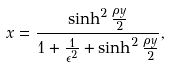Convert formula to latex. <formula><loc_0><loc_0><loc_500><loc_500>x = \frac { \sinh ^ { 2 } \frac { \rho y } { 2 } } { { 1 + \frac { 1 } { \epsilon ^ { 2 } } + \sinh ^ { 2 } \frac { \rho y } { 2 } } } ,</formula> 